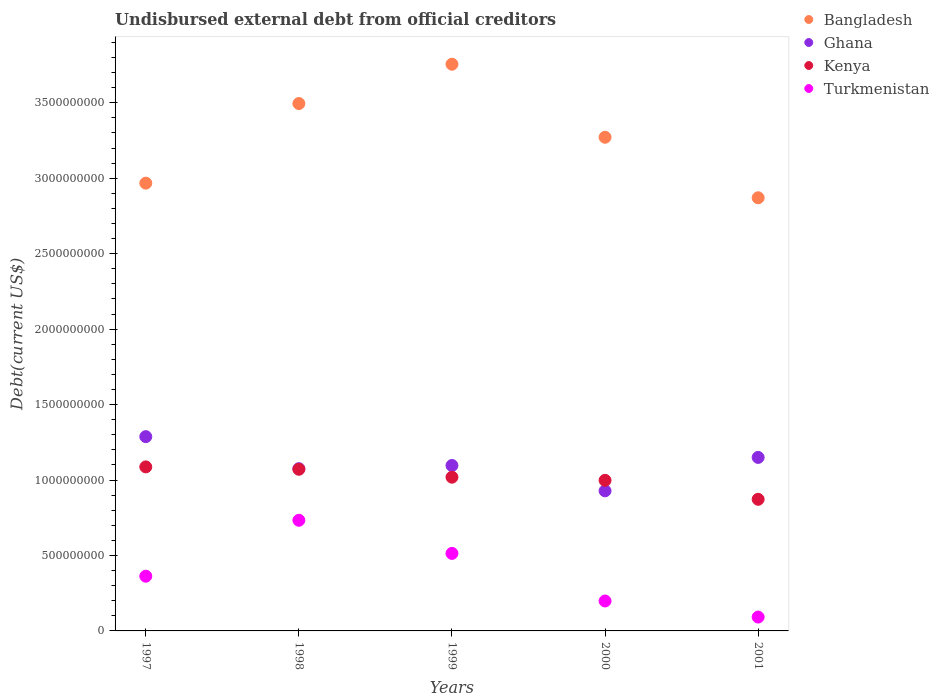What is the total debt in Ghana in 1997?
Make the answer very short. 1.29e+09. Across all years, what is the maximum total debt in Ghana?
Offer a very short reply. 1.29e+09. Across all years, what is the minimum total debt in Ghana?
Keep it short and to the point. 9.28e+08. In which year was the total debt in Kenya maximum?
Keep it short and to the point. 1997. What is the total total debt in Ghana in the graph?
Make the answer very short. 5.54e+09. What is the difference between the total debt in Ghana in 1999 and that in 2000?
Provide a succinct answer. 1.68e+08. What is the difference between the total debt in Kenya in 1998 and the total debt in Ghana in 2001?
Your response must be concise. -7.85e+07. What is the average total debt in Ghana per year?
Offer a very short reply. 1.11e+09. In the year 1997, what is the difference between the total debt in Turkmenistan and total debt in Kenya?
Offer a terse response. -7.24e+08. What is the ratio of the total debt in Bangladesh in 1997 to that in 1999?
Provide a short and direct response. 0.79. Is the total debt in Bangladesh in 1998 less than that in 2000?
Provide a succinct answer. No. What is the difference between the highest and the second highest total debt in Kenya?
Offer a very short reply. 1.57e+07. What is the difference between the highest and the lowest total debt in Kenya?
Offer a terse response. 2.15e+08. Is it the case that in every year, the sum of the total debt in Kenya and total debt in Bangladesh  is greater than the sum of total debt in Ghana and total debt in Turkmenistan?
Your answer should be very brief. Yes. Is the total debt in Turkmenistan strictly greater than the total debt in Bangladesh over the years?
Keep it short and to the point. No. Is the total debt in Turkmenistan strictly less than the total debt in Kenya over the years?
Your answer should be very brief. Yes. How many years are there in the graph?
Provide a succinct answer. 5. Does the graph contain any zero values?
Offer a very short reply. No. How many legend labels are there?
Give a very brief answer. 4. How are the legend labels stacked?
Provide a short and direct response. Vertical. What is the title of the graph?
Give a very brief answer. Undisbursed external debt from official creditors. What is the label or title of the Y-axis?
Provide a short and direct response. Debt(current US$). What is the Debt(current US$) in Bangladesh in 1997?
Your answer should be compact. 2.97e+09. What is the Debt(current US$) in Ghana in 1997?
Your answer should be very brief. 1.29e+09. What is the Debt(current US$) in Kenya in 1997?
Offer a very short reply. 1.09e+09. What is the Debt(current US$) in Turkmenistan in 1997?
Your answer should be very brief. 3.63e+08. What is the Debt(current US$) of Bangladesh in 1998?
Your answer should be compact. 3.49e+09. What is the Debt(current US$) of Ghana in 1998?
Make the answer very short. 1.08e+09. What is the Debt(current US$) in Kenya in 1998?
Offer a terse response. 1.07e+09. What is the Debt(current US$) in Turkmenistan in 1998?
Offer a very short reply. 7.33e+08. What is the Debt(current US$) of Bangladesh in 1999?
Your answer should be very brief. 3.76e+09. What is the Debt(current US$) of Ghana in 1999?
Provide a short and direct response. 1.10e+09. What is the Debt(current US$) in Kenya in 1999?
Give a very brief answer. 1.02e+09. What is the Debt(current US$) of Turkmenistan in 1999?
Your answer should be very brief. 5.14e+08. What is the Debt(current US$) in Bangladesh in 2000?
Offer a very short reply. 3.27e+09. What is the Debt(current US$) in Ghana in 2000?
Provide a succinct answer. 9.28e+08. What is the Debt(current US$) of Kenya in 2000?
Give a very brief answer. 9.98e+08. What is the Debt(current US$) in Turkmenistan in 2000?
Provide a succinct answer. 1.98e+08. What is the Debt(current US$) of Bangladesh in 2001?
Provide a short and direct response. 2.87e+09. What is the Debt(current US$) of Ghana in 2001?
Give a very brief answer. 1.15e+09. What is the Debt(current US$) in Kenya in 2001?
Your answer should be very brief. 8.72e+08. What is the Debt(current US$) of Turkmenistan in 2001?
Offer a terse response. 9.19e+07. Across all years, what is the maximum Debt(current US$) in Bangladesh?
Keep it short and to the point. 3.76e+09. Across all years, what is the maximum Debt(current US$) of Ghana?
Keep it short and to the point. 1.29e+09. Across all years, what is the maximum Debt(current US$) in Kenya?
Your answer should be compact. 1.09e+09. Across all years, what is the maximum Debt(current US$) in Turkmenistan?
Provide a short and direct response. 7.33e+08. Across all years, what is the minimum Debt(current US$) in Bangladesh?
Your answer should be compact. 2.87e+09. Across all years, what is the minimum Debt(current US$) in Ghana?
Ensure brevity in your answer.  9.28e+08. Across all years, what is the minimum Debt(current US$) of Kenya?
Make the answer very short. 8.72e+08. Across all years, what is the minimum Debt(current US$) of Turkmenistan?
Your response must be concise. 9.19e+07. What is the total Debt(current US$) of Bangladesh in the graph?
Give a very brief answer. 1.64e+1. What is the total Debt(current US$) in Ghana in the graph?
Give a very brief answer. 5.54e+09. What is the total Debt(current US$) of Kenya in the graph?
Keep it short and to the point. 5.05e+09. What is the total Debt(current US$) of Turkmenistan in the graph?
Make the answer very short. 1.90e+09. What is the difference between the Debt(current US$) of Bangladesh in 1997 and that in 1998?
Give a very brief answer. -5.28e+08. What is the difference between the Debt(current US$) in Ghana in 1997 and that in 1998?
Make the answer very short. 2.12e+08. What is the difference between the Debt(current US$) of Kenya in 1997 and that in 1998?
Provide a short and direct response. 1.57e+07. What is the difference between the Debt(current US$) in Turkmenistan in 1997 and that in 1998?
Make the answer very short. -3.71e+08. What is the difference between the Debt(current US$) in Bangladesh in 1997 and that in 1999?
Ensure brevity in your answer.  -7.88e+08. What is the difference between the Debt(current US$) of Ghana in 1997 and that in 1999?
Offer a very short reply. 1.91e+08. What is the difference between the Debt(current US$) in Kenya in 1997 and that in 1999?
Give a very brief answer. 6.82e+07. What is the difference between the Debt(current US$) of Turkmenistan in 1997 and that in 1999?
Give a very brief answer. -1.51e+08. What is the difference between the Debt(current US$) of Bangladesh in 1997 and that in 2000?
Offer a terse response. -3.04e+08. What is the difference between the Debt(current US$) in Ghana in 1997 and that in 2000?
Provide a succinct answer. 3.59e+08. What is the difference between the Debt(current US$) of Kenya in 1997 and that in 2000?
Your response must be concise. 8.91e+07. What is the difference between the Debt(current US$) of Turkmenistan in 1997 and that in 2000?
Offer a very short reply. 1.64e+08. What is the difference between the Debt(current US$) in Bangladesh in 1997 and that in 2001?
Your answer should be very brief. 9.69e+07. What is the difference between the Debt(current US$) in Ghana in 1997 and that in 2001?
Provide a short and direct response. 1.38e+08. What is the difference between the Debt(current US$) in Kenya in 1997 and that in 2001?
Offer a terse response. 2.15e+08. What is the difference between the Debt(current US$) of Turkmenistan in 1997 and that in 2001?
Your response must be concise. 2.71e+08. What is the difference between the Debt(current US$) in Bangladesh in 1998 and that in 1999?
Your answer should be very brief. -2.61e+08. What is the difference between the Debt(current US$) in Ghana in 1998 and that in 1999?
Keep it short and to the point. -2.11e+07. What is the difference between the Debt(current US$) of Kenya in 1998 and that in 1999?
Provide a succinct answer. 5.25e+07. What is the difference between the Debt(current US$) of Turkmenistan in 1998 and that in 1999?
Ensure brevity in your answer.  2.20e+08. What is the difference between the Debt(current US$) in Bangladesh in 1998 and that in 2000?
Keep it short and to the point. 2.23e+08. What is the difference between the Debt(current US$) of Ghana in 1998 and that in 2000?
Give a very brief answer. 1.47e+08. What is the difference between the Debt(current US$) in Kenya in 1998 and that in 2000?
Your answer should be very brief. 7.34e+07. What is the difference between the Debt(current US$) in Turkmenistan in 1998 and that in 2000?
Your answer should be very brief. 5.35e+08. What is the difference between the Debt(current US$) in Bangladesh in 1998 and that in 2001?
Ensure brevity in your answer.  6.24e+08. What is the difference between the Debt(current US$) of Ghana in 1998 and that in 2001?
Offer a very short reply. -7.46e+07. What is the difference between the Debt(current US$) of Kenya in 1998 and that in 2001?
Give a very brief answer. 1.99e+08. What is the difference between the Debt(current US$) in Turkmenistan in 1998 and that in 2001?
Your answer should be compact. 6.41e+08. What is the difference between the Debt(current US$) of Bangladesh in 1999 and that in 2000?
Offer a very short reply. 4.84e+08. What is the difference between the Debt(current US$) of Ghana in 1999 and that in 2000?
Ensure brevity in your answer.  1.68e+08. What is the difference between the Debt(current US$) of Kenya in 1999 and that in 2000?
Your answer should be very brief. 2.09e+07. What is the difference between the Debt(current US$) of Turkmenistan in 1999 and that in 2000?
Provide a short and direct response. 3.15e+08. What is the difference between the Debt(current US$) in Bangladesh in 1999 and that in 2001?
Provide a short and direct response. 8.85e+08. What is the difference between the Debt(current US$) of Ghana in 1999 and that in 2001?
Provide a short and direct response. -5.35e+07. What is the difference between the Debt(current US$) in Kenya in 1999 and that in 2001?
Your answer should be very brief. 1.47e+08. What is the difference between the Debt(current US$) in Turkmenistan in 1999 and that in 2001?
Keep it short and to the point. 4.22e+08. What is the difference between the Debt(current US$) of Bangladesh in 2000 and that in 2001?
Provide a short and direct response. 4.01e+08. What is the difference between the Debt(current US$) in Ghana in 2000 and that in 2001?
Ensure brevity in your answer.  -2.22e+08. What is the difference between the Debt(current US$) of Kenya in 2000 and that in 2001?
Offer a very short reply. 1.26e+08. What is the difference between the Debt(current US$) of Turkmenistan in 2000 and that in 2001?
Provide a short and direct response. 1.07e+08. What is the difference between the Debt(current US$) of Bangladesh in 1997 and the Debt(current US$) of Ghana in 1998?
Provide a short and direct response. 1.89e+09. What is the difference between the Debt(current US$) of Bangladesh in 1997 and the Debt(current US$) of Kenya in 1998?
Provide a short and direct response. 1.90e+09. What is the difference between the Debt(current US$) of Bangladesh in 1997 and the Debt(current US$) of Turkmenistan in 1998?
Your answer should be compact. 2.23e+09. What is the difference between the Debt(current US$) of Ghana in 1997 and the Debt(current US$) of Kenya in 1998?
Your response must be concise. 2.16e+08. What is the difference between the Debt(current US$) of Ghana in 1997 and the Debt(current US$) of Turkmenistan in 1998?
Your answer should be very brief. 5.54e+08. What is the difference between the Debt(current US$) of Kenya in 1997 and the Debt(current US$) of Turkmenistan in 1998?
Provide a succinct answer. 3.54e+08. What is the difference between the Debt(current US$) of Bangladesh in 1997 and the Debt(current US$) of Ghana in 1999?
Provide a short and direct response. 1.87e+09. What is the difference between the Debt(current US$) of Bangladesh in 1997 and the Debt(current US$) of Kenya in 1999?
Your response must be concise. 1.95e+09. What is the difference between the Debt(current US$) of Bangladesh in 1997 and the Debt(current US$) of Turkmenistan in 1999?
Give a very brief answer. 2.45e+09. What is the difference between the Debt(current US$) in Ghana in 1997 and the Debt(current US$) in Kenya in 1999?
Provide a succinct answer. 2.69e+08. What is the difference between the Debt(current US$) in Ghana in 1997 and the Debt(current US$) in Turkmenistan in 1999?
Your answer should be compact. 7.74e+08. What is the difference between the Debt(current US$) in Kenya in 1997 and the Debt(current US$) in Turkmenistan in 1999?
Your response must be concise. 5.73e+08. What is the difference between the Debt(current US$) in Bangladesh in 1997 and the Debt(current US$) in Ghana in 2000?
Make the answer very short. 2.04e+09. What is the difference between the Debt(current US$) of Bangladesh in 1997 and the Debt(current US$) of Kenya in 2000?
Offer a terse response. 1.97e+09. What is the difference between the Debt(current US$) of Bangladesh in 1997 and the Debt(current US$) of Turkmenistan in 2000?
Keep it short and to the point. 2.77e+09. What is the difference between the Debt(current US$) in Ghana in 1997 and the Debt(current US$) in Kenya in 2000?
Give a very brief answer. 2.90e+08. What is the difference between the Debt(current US$) of Ghana in 1997 and the Debt(current US$) of Turkmenistan in 2000?
Make the answer very short. 1.09e+09. What is the difference between the Debt(current US$) of Kenya in 1997 and the Debt(current US$) of Turkmenistan in 2000?
Provide a short and direct response. 8.89e+08. What is the difference between the Debt(current US$) of Bangladesh in 1997 and the Debt(current US$) of Ghana in 2001?
Make the answer very short. 1.82e+09. What is the difference between the Debt(current US$) of Bangladesh in 1997 and the Debt(current US$) of Kenya in 2001?
Your answer should be very brief. 2.10e+09. What is the difference between the Debt(current US$) of Bangladesh in 1997 and the Debt(current US$) of Turkmenistan in 2001?
Keep it short and to the point. 2.88e+09. What is the difference between the Debt(current US$) in Ghana in 1997 and the Debt(current US$) in Kenya in 2001?
Offer a terse response. 4.15e+08. What is the difference between the Debt(current US$) of Ghana in 1997 and the Debt(current US$) of Turkmenistan in 2001?
Provide a succinct answer. 1.20e+09. What is the difference between the Debt(current US$) of Kenya in 1997 and the Debt(current US$) of Turkmenistan in 2001?
Offer a terse response. 9.95e+08. What is the difference between the Debt(current US$) of Bangladesh in 1998 and the Debt(current US$) of Ghana in 1999?
Your answer should be compact. 2.40e+09. What is the difference between the Debt(current US$) of Bangladesh in 1998 and the Debt(current US$) of Kenya in 1999?
Offer a terse response. 2.48e+09. What is the difference between the Debt(current US$) in Bangladesh in 1998 and the Debt(current US$) in Turkmenistan in 1999?
Provide a succinct answer. 2.98e+09. What is the difference between the Debt(current US$) in Ghana in 1998 and the Debt(current US$) in Kenya in 1999?
Provide a succinct answer. 5.64e+07. What is the difference between the Debt(current US$) of Ghana in 1998 and the Debt(current US$) of Turkmenistan in 1999?
Give a very brief answer. 5.61e+08. What is the difference between the Debt(current US$) of Kenya in 1998 and the Debt(current US$) of Turkmenistan in 1999?
Provide a short and direct response. 5.58e+08. What is the difference between the Debt(current US$) of Bangladesh in 1998 and the Debt(current US$) of Ghana in 2000?
Give a very brief answer. 2.57e+09. What is the difference between the Debt(current US$) of Bangladesh in 1998 and the Debt(current US$) of Kenya in 2000?
Your answer should be compact. 2.50e+09. What is the difference between the Debt(current US$) of Bangladesh in 1998 and the Debt(current US$) of Turkmenistan in 2000?
Offer a terse response. 3.30e+09. What is the difference between the Debt(current US$) of Ghana in 1998 and the Debt(current US$) of Kenya in 2000?
Your answer should be compact. 7.72e+07. What is the difference between the Debt(current US$) in Ghana in 1998 and the Debt(current US$) in Turkmenistan in 2000?
Give a very brief answer. 8.77e+08. What is the difference between the Debt(current US$) in Kenya in 1998 and the Debt(current US$) in Turkmenistan in 2000?
Make the answer very short. 8.73e+08. What is the difference between the Debt(current US$) in Bangladesh in 1998 and the Debt(current US$) in Ghana in 2001?
Give a very brief answer. 2.35e+09. What is the difference between the Debt(current US$) in Bangladesh in 1998 and the Debt(current US$) in Kenya in 2001?
Your response must be concise. 2.62e+09. What is the difference between the Debt(current US$) in Bangladesh in 1998 and the Debt(current US$) in Turkmenistan in 2001?
Give a very brief answer. 3.40e+09. What is the difference between the Debt(current US$) in Ghana in 1998 and the Debt(current US$) in Kenya in 2001?
Make the answer very short. 2.03e+08. What is the difference between the Debt(current US$) in Ghana in 1998 and the Debt(current US$) in Turkmenistan in 2001?
Your answer should be very brief. 9.83e+08. What is the difference between the Debt(current US$) in Kenya in 1998 and the Debt(current US$) in Turkmenistan in 2001?
Keep it short and to the point. 9.79e+08. What is the difference between the Debt(current US$) of Bangladesh in 1999 and the Debt(current US$) of Ghana in 2000?
Your answer should be compact. 2.83e+09. What is the difference between the Debt(current US$) of Bangladesh in 1999 and the Debt(current US$) of Kenya in 2000?
Ensure brevity in your answer.  2.76e+09. What is the difference between the Debt(current US$) of Bangladesh in 1999 and the Debt(current US$) of Turkmenistan in 2000?
Provide a short and direct response. 3.56e+09. What is the difference between the Debt(current US$) in Ghana in 1999 and the Debt(current US$) in Kenya in 2000?
Ensure brevity in your answer.  9.83e+07. What is the difference between the Debt(current US$) in Ghana in 1999 and the Debt(current US$) in Turkmenistan in 2000?
Make the answer very short. 8.98e+08. What is the difference between the Debt(current US$) of Kenya in 1999 and the Debt(current US$) of Turkmenistan in 2000?
Offer a terse response. 8.20e+08. What is the difference between the Debt(current US$) of Bangladesh in 1999 and the Debt(current US$) of Ghana in 2001?
Your answer should be very brief. 2.61e+09. What is the difference between the Debt(current US$) of Bangladesh in 1999 and the Debt(current US$) of Kenya in 2001?
Provide a short and direct response. 2.88e+09. What is the difference between the Debt(current US$) of Bangladesh in 1999 and the Debt(current US$) of Turkmenistan in 2001?
Provide a short and direct response. 3.66e+09. What is the difference between the Debt(current US$) in Ghana in 1999 and the Debt(current US$) in Kenya in 2001?
Offer a terse response. 2.24e+08. What is the difference between the Debt(current US$) in Ghana in 1999 and the Debt(current US$) in Turkmenistan in 2001?
Give a very brief answer. 1.00e+09. What is the difference between the Debt(current US$) in Kenya in 1999 and the Debt(current US$) in Turkmenistan in 2001?
Offer a very short reply. 9.27e+08. What is the difference between the Debt(current US$) of Bangladesh in 2000 and the Debt(current US$) of Ghana in 2001?
Offer a terse response. 2.12e+09. What is the difference between the Debt(current US$) in Bangladesh in 2000 and the Debt(current US$) in Kenya in 2001?
Your answer should be very brief. 2.40e+09. What is the difference between the Debt(current US$) of Bangladesh in 2000 and the Debt(current US$) of Turkmenistan in 2001?
Your answer should be very brief. 3.18e+09. What is the difference between the Debt(current US$) in Ghana in 2000 and the Debt(current US$) in Kenya in 2001?
Make the answer very short. 5.60e+07. What is the difference between the Debt(current US$) of Ghana in 2000 and the Debt(current US$) of Turkmenistan in 2001?
Your response must be concise. 8.36e+08. What is the difference between the Debt(current US$) of Kenya in 2000 and the Debt(current US$) of Turkmenistan in 2001?
Keep it short and to the point. 9.06e+08. What is the average Debt(current US$) of Bangladesh per year?
Your response must be concise. 3.27e+09. What is the average Debt(current US$) in Ghana per year?
Ensure brevity in your answer.  1.11e+09. What is the average Debt(current US$) in Kenya per year?
Offer a very short reply. 1.01e+09. What is the average Debt(current US$) in Turkmenistan per year?
Keep it short and to the point. 3.80e+08. In the year 1997, what is the difference between the Debt(current US$) of Bangladesh and Debt(current US$) of Ghana?
Your answer should be very brief. 1.68e+09. In the year 1997, what is the difference between the Debt(current US$) in Bangladesh and Debt(current US$) in Kenya?
Make the answer very short. 1.88e+09. In the year 1997, what is the difference between the Debt(current US$) in Bangladesh and Debt(current US$) in Turkmenistan?
Your answer should be very brief. 2.60e+09. In the year 1997, what is the difference between the Debt(current US$) in Ghana and Debt(current US$) in Kenya?
Offer a very short reply. 2.01e+08. In the year 1997, what is the difference between the Debt(current US$) of Ghana and Debt(current US$) of Turkmenistan?
Keep it short and to the point. 9.25e+08. In the year 1997, what is the difference between the Debt(current US$) of Kenya and Debt(current US$) of Turkmenistan?
Offer a terse response. 7.24e+08. In the year 1998, what is the difference between the Debt(current US$) in Bangladesh and Debt(current US$) in Ghana?
Make the answer very short. 2.42e+09. In the year 1998, what is the difference between the Debt(current US$) in Bangladesh and Debt(current US$) in Kenya?
Make the answer very short. 2.42e+09. In the year 1998, what is the difference between the Debt(current US$) in Bangladesh and Debt(current US$) in Turkmenistan?
Your answer should be compact. 2.76e+09. In the year 1998, what is the difference between the Debt(current US$) of Ghana and Debt(current US$) of Kenya?
Provide a short and direct response. 3.90e+06. In the year 1998, what is the difference between the Debt(current US$) of Ghana and Debt(current US$) of Turkmenistan?
Your answer should be compact. 3.42e+08. In the year 1998, what is the difference between the Debt(current US$) in Kenya and Debt(current US$) in Turkmenistan?
Give a very brief answer. 3.38e+08. In the year 1999, what is the difference between the Debt(current US$) of Bangladesh and Debt(current US$) of Ghana?
Ensure brevity in your answer.  2.66e+09. In the year 1999, what is the difference between the Debt(current US$) of Bangladesh and Debt(current US$) of Kenya?
Make the answer very short. 2.74e+09. In the year 1999, what is the difference between the Debt(current US$) of Bangladesh and Debt(current US$) of Turkmenistan?
Your response must be concise. 3.24e+09. In the year 1999, what is the difference between the Debt(current US$) of Ghana and Debt(current US$) of Kenya?
Offer a very short reply. 7.75e+07. In the year 1999, what is the difference between the Debt(current US$) of Ghana and Debt(current US$) of Turkmenistan?
Provide a short and direct response. 5.83e+08. In the year 1999, what is the difference between the Debt(current US$) of Kenya and Debt(current US$) of Turkmenistan?
Make the answer very short. 5.05e+08. In the year 2000, what is the difference between the Debt(current US$) of Bangladesh and Debt(current US$) of Ghana?
Offer a terse response. 2.34e+09. In the year 2000, what is the difference between the Debt(current US$) of Bangladesh and Debt(current US$) of Kenya?
Provide a succinct answer. 2.27e+09. In the year 2000, what is the difference between the Debt(current US$) in Bangladesh and Debt(current US$) in Turkmenistan?
Offer a very short reply. 3.07e+09. In the year 2000, what is the difference between the Debt(current US$) in Ghana and Debt(current US$) in Kenya?
Provide a succinct answer. -6.97e+07. In the year 2000, what is the difference between the Debt(current US$) in Ghana and Debt(current US$) in Turkmenistan?
Ensure brevity in your answer.  7.30e+08. In the year 2000, what is the difference between the Debt(current US$) in Kenya and Debt(current US$) in Turkmenistan?
Offer a terse response. 7.99e+08. In the year 2001, what is the difference between the Debt(current US$) in Bangladesh and Debt(current US$) in Ghana?
Your response must be concise. 1.72e+09. In the year 2001, what is the difference between the Debt(current US$) of Bangladesh and Debt(current US$) of Kenya?
Ensure brevity in your answer.  2.00e+09. In the year 2001, what is the difference between the Debt(current US$) of Bangladesh and Debt(current US$) of Turkmenistan?
Your response must be concise. 2.78e+09. In the year 2001, what is the difference between the Debt(current US$) of Ghana and Debt(current US$) of Kenya?
Provide a succinct answer. 2.78e+08. In the year 2001, what is the difference between the Debt(current US$) in Ghana and Debt(current US$) in Turkmenistan?
Ensure brevity in your answer.  1.06e+09. In the year 2001, what is the difference between the Debt(current US$) of Kenya and Debt(current US$) of Turkmenistan?
Make the answer very short. 7.80e+08. What is the ratio of the Debt(current US$) in Bangladesh in 1997 to that in 1998?
Provide a succinct answer. 0.85. What is the ratio of the Debt(current US$) in Ghana in 1997 to that in 1998?
Ensure brevity in your answer.  1.2. What is the ratio of the Debt(current US$) of Kenya in 1997 to that in 1998?
Provide a succinct answer. 1.01. What is the ratio of the Debt(current US$) in Turkmenistan in 1997 to that in 1998?
Offer a terse response. 0.49. What is the ratio of the Debt(current US$) of Bangladesh in 1997 to that in 1999?
Keep it short and to the point. 0.79. What is the ratio of the Debt(current US$) of Ghana in 1997 to that in 1999?
Offer a terse response. 1.17. What is the ratio of the Debt(current US$) of Kenya in 1997 to that in 1999?
Ensure brevity in your answer.  1.07. What is the ratio of the Debt(current US$) in Turkmenistan in 1997 to that in 1999?
Make the answer very short. 0.71. What is the ratio of the Debt(current US$) in Bangladesh in 1997 to that in 2000?
Your response must be concise. 0.91. What is the ratio of the Debt(current US$) of Ghana in 1997 to that in 2000?
Keep it short and to the point. 1.39. What is the ratio of the Debt(current US$) of Kenya in 1997 to that in 2000?
Provide a succinct answer. 1.09. What is the ratio of the Debt(current US$) of Turkmenistan in 1997 to that in 2000?
Offer a terse response. 1.83. What is the ratio of the Debt(current US$) in Bangladesh in 1997 to that in 2001?
Give a very brief answer. 1.03. What is the ratio of the Debt(current US$) in Ghana in 1997 to that in 2001?
Your response must be concise. 1.12. What is the ratio of the Debt(current US$) in Kenya in 1997 to that in 2001?
Provide a short and direct response. 1.25. What is the ratio of the Debt(current US$) in Turkmenistan in 1997 to that in 2001?
Make the answer very short. 3.95. What is the ratio of the Debt(current US$) in Bangladesh in 1998 to that in 1999?
Provide a short and direct response. 0.93. What is the ratio of the Debt(current US$) of Ghana in 1998 to that in 1999?
Your answer should be very brief. 0.98. What is the ratio of the Debt(current US$) of Kenya in 1998 to that in 1999?
Provide a succinct answer. 1.05. What is the ratio of the Debt(current US$) of Turkmenistan in 1998 to that in 1999?
Your answer should be very brief. 1.43. What is the ratio of the Debt(current US$) of Bangladesh in 1998 to that in 2000?
Give a very brief answer. 1.07. What is the ratio of the Debt(current US$) in Ghana in 1998 to that in 2000?
Give a very brief answer. 1.16. What is the ratio of the Debt(current US$) of Kenya in 1998 to that in 2000?
Provide a short and direct response. 1.07. What is the ratio of the Debt(current US$) in Turkmenistan in 1998 to that in 2000?
Your answer should be very brief. 3.7. What is the ratio of the Debt(current US$) of Bangladesh in 1998 to that in 2001?
Your answer should be compact. 1.22. What is the ratio of the Debt(current US$) of Ghana in 1998 to that in 2001?
Your answer should be very brief. 0.94. What is the ratio of the Debt(current US$) in Kenya in 1998 to that in 2001?
Your answer should be very brief. 1.23. What is the ratio of the Debt(current US$) in Turkmenistan in 1998 to that in 2001?
Ensure brevity in your answer.  7.98. What is the ratio of the Debt(current US$) of Bangladesh in 1999 to that in 2000?
Offer a very short reply. 1.15. What is the ratio of the Debt(current US$) of Ghana in 1999 to that in 2000?
Your answer should be very brief. 1.18. What is the ratio of the Debt(current US$) of Kenya in 1999 to that in 2000?
Provide a short and direct response. 1.02. What is the ratio of the Debt(current US$) of Turkmenistan in 1999 to that in 2000?
Your answer should be very brief. 2.59. What is the ratio of the Debt(current US$) of Bangladesh in 1999 to that in 2001?
Your response must be concise. 1.31. What is the ratio of the Debt(current US$) in Ghana in 1999 to that in 2001?
Provide a succinct answer. 0.95. What is the ratio of the Debt(current US$) of Kenya in 1999 to that in 2001?
Your response must be concise. 1.17. What is the ratio of the Debt(current US$) of Turkmenistan in 1999 to that in 2001?
Give a very brief answer. 5.59. What is the ratio of the Debt(current US$) in Bangladesh in 2000 to that in 2001?
Make the answer very short. 1.14. What is the ratio of the Debt(current US$) in Ghana in 2000 to that in 2001?
Make the answer very short. 0.81. What is the ratio of the Debt(current US$) in Kenya in 2000 to that in 2001?
Ensure brevity in your answer.  1.14. What is the ratio of the Debt(current US$) in Turkmenistan in 2000 to that in 2001?
Make the answer very short. 2.16. What is the difference between the highest and the second highest Debt(current US$) of Bangladesh?
Offer a very short reply. 2.61e+08. What is the difference between the highest and the second highest Debt(current US$) of Ghana?
Give a very brief answer. 1.38e+08. What is the difference between the highest and the second highest Debt(current US$) in Kenya?
Provide a short and direct response. 1.57e+07. What is the difference between the highest and the second highest Debt(current US$) of Turkmenistan?
Give a very brief answer. 2.20e+08. What is the difference between the highest and the lowest Debt(current US$) in Bangladesh?
Your answer should be compact. 8.85e+08. What is the difference between the highest and the lowest Debt(current US$) in Ghana?
Your response must be concise. 3.59e+08. What is the difference between the highest and the lowest Debt(current US$) of Kenya?
Offer a very short reply. 2.15e+08. What is the difference between the highest and the lowest Debt(current US$) in Turkmenistan?
Offer a terse response. 6.41e+08. 